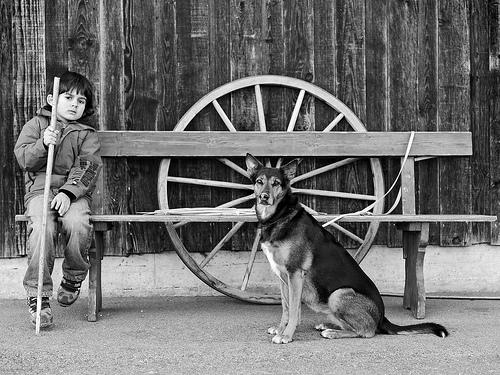Count the number of legs of the German Shepherd dog. The German Shepherd dog has four legs. List a few distinguishing physical features of the dog. The dog has tall ears, a dark tail, and is a beautiful German Shepherd breed. Determine whether the dog is leashed or not and provide a brief explanation for your answer. Yes, the dog is leashed, as there is a leash connecting the dog to the park bench, ensuring the dog remains close to the child and the bench. Identify three details about the boy and his attire. The boy has dark hair, is wearing a coat with patches on the sleeve, and sneakers with dark shoelaces. Describe the surroundings of the main subjects in the image. The main subjects are surrounded by an old wooden wagon wheel, a wooden homemade bench, a wooden paneled exterior wall, and dirt ground. Analyze the interaction between the child and the dog in the image. The child and the dog seem to be peacefully coexisting, sitting and resting together in an outdoor setting, suggesting a sense of companionship and trust. Provide a brief overview of the scene and the main objects present in the image. The scene captures a young boy sitting on a wooden bench next to a German Shepherd dog, with an old wooden wagon wheel behind them, and a wooden wall in the background. What emotion or sentiment can be inferred from the image? The image conveys a sense of tranquility, companionship, and simple pleasure in spending time with a loved one, in this case, a child and their dog in an outdoor setting. How would you evaluate the quality of the image from an artistic perspective? The image is rich in detail and provides diverse elements that allow for deep observation and interpretation, making it a compelling and engaging subject for artistic analysis. What are the main subjects in the image and what are they involved in? A young child is sitting on a wooden bench holding a stick, while a medium to large sized German Shepherd dog sits nearby, leashed to the bench. They are both in front of an old wooden wagon wheel and wooden wall. 